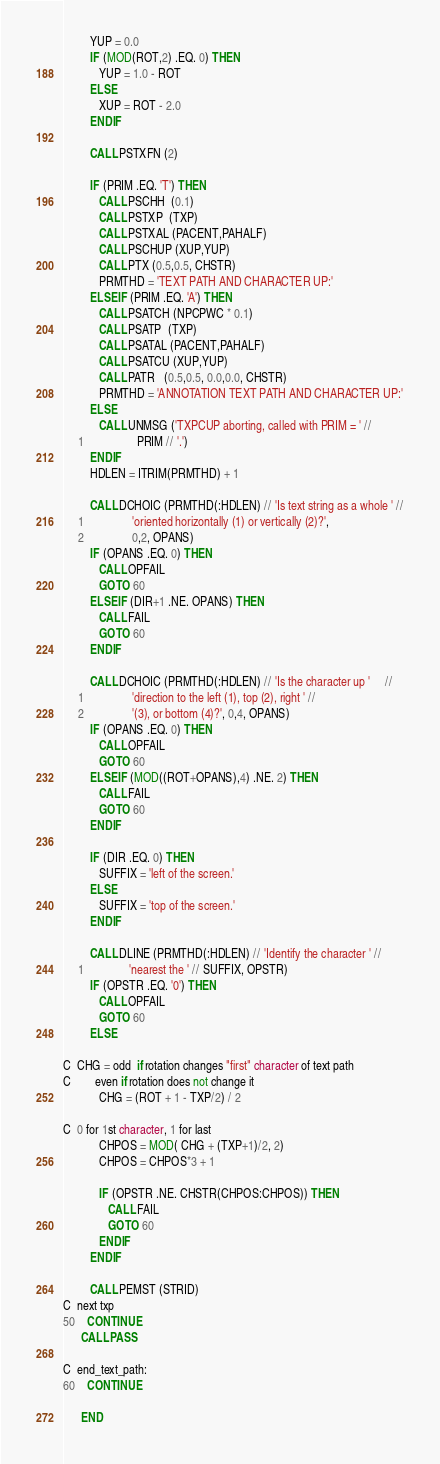<code> <loc_0><loc_0><loc_500><loc_500><_FORTRAN_>         YUP = 0.0
         IF (MOD(ROT,2) .EQ. 0) THEN
            YUP = 1.0 - ROT
         ELSE
            XUP = ROT - 2.0
         ENDIF

         CALL PSTXFN (2)

         IF (PRIM .EQ. 'T') THEN
            CALL PSCHH  (0.1)
            CALL PSTXP  (TXP)
            CALL PSTXAL (PACENT,PAHALF)
            CALL PSCHUP (XUP,YUP)
            CALL PTX (0.5,0.5, CHSTR)
            PRMTHD = 'TEXT PATH AND CHARACTER UP:'
         ELSEIF (PRIM .EQ. 'A') THEN
            CALL PSATCH (NPCPWC * 0.1)
            CALL PSATP  (TXP)
            CALL PSATAL (PACENT,PAHALF)
            CALL PSATCU (XUP,YUP)
            CALL PATR   (0.5,0.5, 0.0,0.0, CHSTR)
            PRMTHD = 'ANNOTATION TEXT PATH AND CHARACTER UP:'
         ELSE
            CALL UNMSG ('TXPCUP aborting, called with PRIM = ' //
     1                  PRIM // '.')
         ENDIF
         HDLEN = ITRIM(PRMTHD) + 1

         CALL DCHOIC (PRMTHD(:HDLEN) // 'Is text string as a whole ' //
     1                'oriented horizontally (1) or vertically (2)?',
     2                0,2, OPANS)
         IF (OPANS .EQ. 0) THEN
            CALL OPFAIL
            GOTO 60
         ELSEIF (DIR+1 .NE. OPANS) THEN
            CALL FAIL
            GOTO 60
         ENDIF

         CALL DCHOIC (PRMTHD(:HDLEN) // 'Is the character up '     //
     1                'direction to the left (1), top (2), right ' //
     2                '(3), or bottom (4)?', 0,4, OPANS)
         IF (OPANS .EQ. 0) THEN
            CALL OPFAIL
            GOTO 60
         ELSEIF (MOD((ROT+OPANS),4) .NE. 2) THEN
            CALL FAIL
            GOTO 60
         ENDIF

         IF (DIR .EQ. 0) THEN
            SUFFIX = 'left of the screen.'
         ELSE
            SUFFIX = 'top of the screen.'
         ENDIF

         CALL DLINE (PRMTHD(:HDLEN) // 'Identify the character ' //
     1               'nearest the ' // SUFFIX, OPSTR)
         IF (OPSTR .EQ. '0') THEN
            CALL OPFAIL
            GOTO 60
         ELSE

C  CHG = odd  if rotation changes "first" character of text path
C        even if rotation does not change it
            CHG = (ROT + 1 - TXP/2) / 2

C  0 for 1st character, 1 for last
            CHPOS = MOD( CHG + (TXP+1)/2, 2)
            CHPOS = CHPOS*3 + 1

            IF (OPSTR .NE. CHSTR(CHPOS:CHPOS)) THEN
               CALL FAIL
               GOTO 60
            ENDIF
         ENDIF

         CALL PEMST (STRID)
C  next txp
50    CONTINUE
      CALL PASS

C  end_text_path:
60    CONTINUE

      END
</code> 